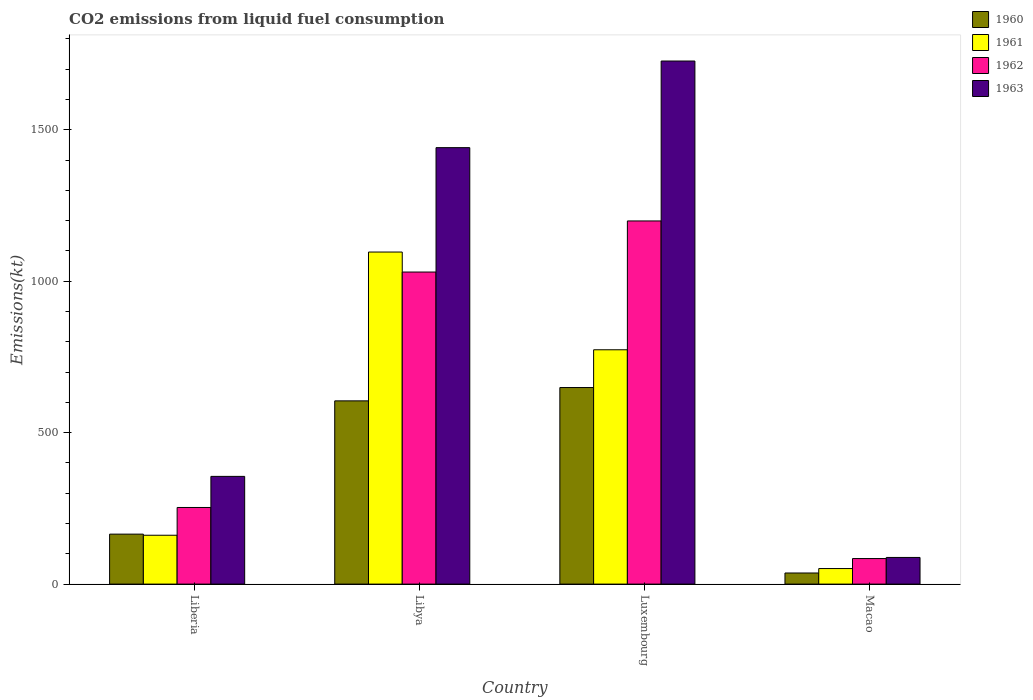How many groups of bars are there?
Your answer should be compact. 4. Are the number of bars on each tick of the X-axis equal?
Your answer should be compact. Yes. How many bars are there on the 2nd tick from the left?
Provide a short and direct response. 4. What is the label of the 3rd group of bars from the left?
Your answer should be very brief. Luxembourg. In how many cases, is the number of bars for a given country not equal to the number of legend labels?
Your answer should be very brief. 0. What is the amount of CO2 emitted in 1960 in Macao?
Your response must be concise. 36.67. Across all countries, what is the maximum amount of CO2 emitted in 1961?
Make the answer very short. 1096.43. Across all countries, what is the minimum amount of CO2 emitted in 1962?
Your answer should be very brief. 84.34. In which country was the amount of CO2 emitted in 1962 maximum?
Provide a succinct answer. Luxembourg. In which country was the amount of CO2 emitted in 1963 minimum?
Offer a very short reply. Macao. What is the total amount of CO2 emitted in 1963 in the graph?
Your answer should be very brief. 3611.99. What is the difference between the amount of CO2 emitted in 1960 in Libya and that in Macao?
Your response must be concise. 568.38. What is the difference between the amount of CO2 emitted in 1963 in Luxembourg and the amount of CO2 emitted in 1960 in Liberia?
Your answer should be very brief. 1562.14. What is the average amount of CO2 emitted in 1962 per country?
Ensure brevity in your answer.  641.72. What is the difference between the amount of CO2 emitted of/in 1960 and amount of CO2 emitted of/in 1963 in Liberia?
Offer a terse response. -190.68. In how many countries, is the amount of CO2 emitted in 1963 greater than 900 kt?
Make the answer very short. 2. What is the ratio of the amount of CO2 emitted in 1962 in Liberia to that in Luxembourg?
Ensure brevity in your answer.  0.21. Is the amount of CO2 emitted in 1961 in Luxembourg less than that in Macao?
Give a very brief answer. No. Is the difference between the amount of CO2 emitted in 1960 in Libya and Luxembourg greater than the difference between the amount of CO2 emitted in 1963 in Libya and Luxembourg?
Offer a terse response. Yes. What is the difference between the highest and the second highest amount of CO2 emitted in 1963?
Offer a terse response. 1085.43. What is the difference between the highest and the lowest amount of CO2 emitted in 1961?
Provide a short and direct response. 1045.1. Is the sum of the amount of CO2 emitted in 1961 in Luxembourg and Macao greater than the maximum amount of CO2 emitted in 1960 across all countries?
Offer a terse response. Yes. Is it the case that in every country, the sum of the amount of CO2 emitted in 1963 and amount of CO2 emitted in 1960 is greater than the sum of amount of CO2 emitted in 1961 and amount of CO2 emitted in 1962?
Provide a succinct answer. No. What does the 2nd bar from the left in Liberia represents?
Give a very brief answer. 1961. Is it the case that in every country, the sum of the amount of CO2 emitted in 1962 and amount of CO2 emitted in 1960 is greater than the amount of CO2 emitted in 1961?
Offer a terse response. Yes. How many bars are there?
Keep it short and to the point. 16. How many countries are there in the graph?
Offer a terse response. 4. What is the difference between two consecutive major ticks on the Y-axis?
Give a very brief answer. 500. Does the graph contain any zero values?
Keep it short and to the point. No. How many legend labels are there?
Provide a succinct answer. 4. How are the legend labels stacked?
Your response must be concise. Vertical. What is the title of the graph?
Ensure brevity in your answer.  CO2 emissions from liquid fuel consumption. What is the label or title of the X-axis?
Keep it short and to the point. Country. What is the label or title of the Y-axis?
Provide a succinct answer. Emissions(kt). What is the Emissions(kt) in 1960 in Liberia?
Make the answer very short. 165.01. What is the Emissions(kt) of 1961 in Liberia?
Your response must be concise. 161.35. What is the Emissions(kt) in 1962 in Liberia?
Offer a terse response. 253.02. What is the Emissions(kt) of 1963 in Liberia?
Offer a very short reply. 355.7. What is the Emissions(kt) in 1960 in Libya?
Offer a very short reply. 605.05. What is the Emissions(kt) in 1961 in Libya?
Give a very brief answer. 1096.43. What is the Emissions(kt) in 1962 in Libya?
Your answer should be compact. 1030.43. What is the Emissions(kt) in 1963 in Libya?
Your answer should be very brief. 1441.13. What is the Emissions(kt) of 1960 in Luxembourg?
Give a very brief answer. 649.06. What is the Emissions(kt) of 1961 in Luxembourg?
Give a very brief answer. 773.74. What is the Emissions(kt) of 1962 in Luxembourg?
Provide a succinct answer. 1199.11. What is the Emissions(kt) in 1963 in Luxembourg?
Offer a very short reply. 1727.16. What is the Emissions(kt) of 1960 in Macao?
Offer a terse response. 36.67. What is the Emissions(kt) in 1961 in Macao?
Provide a succinct answer. 51.34. What is the Emissions(kt) of 1962 in Macao?
Offer a very short reply. 84.34. What is the Emissions(kt) in 1963 in Macao?
Your answer should be very brief. 88.01. Across all countries, what is the maximum Emissions(kt) of 1960?
Your response must be concise. 649.06. Across all countries, what is the maximum Emissions(kt) of 1961?
Offer a very short reply. 1096.43. Across all countries, what is the maximum Emissions(kt) of 1962?
Make the answer very short. 1199.11. Across all countries, what is the maximum Emissions(kt) in 1963?
Make the answer very short. 1727.16. Across all countries, what is the minimum Emissions(kt) of 1960?
Ensure brevity in your answer.  36.67. Across all countries, what is the minimum Emissions(kt) in 1961?
Keep it short and to the point. 51.34. Across all countries, what is the minimum Emissions(kt) in 1962?
Your response must be concise. 84.34. Across all countries, what is the minimum Emissions(kt) of 1963?
Give a very brief answer. 88.01. What is the total Emissions(kt) of 1960 in the graph?
Your answer should be compact. 1455.8. What is the total Emissions(kt) in 1961 in the graph?
Ensure brevity in your answer.  2082.86. What is the total Emissions(kt) in 1962 in the graph?
Give a very brief answer. 2566.9. What is the total Emissions(kt) of 1963 in the graph?
Provide a succinct answer. 3611.99. What is the difference between the Emissions(kt) of 1960 in Liberia and that in Libya?
Provide a succinct answer. -440.04. What is the difference between the Emissions(kt) in 1961 in Liberia and that in Libya?
Give a very brief answer. -935.09. What is the difference between the Emissions(kt) in 1962 in Liberia and that in Libya?
Your response must be concise. -777.4. What is the difference between the Emissions(kt) in 1963 in Liberia and that in Libya?
Your answer should be compact. -1085.43. What is the difference between the Emissions(kt) of 1960 in Liberia and that in Luxembourg?
Your answer should be very brief. -484.04. What is the difference between the Emissions(kt) in 1961 in Liberia and that in Luxembourg?
Keep it short and to the point. -612.39. What is the difference between the Emissions(kt) in 1962 in Liberia and that in Luxembourg?
Ensure brevity in your answer.  -946.09. What is the difference between the Emissions(kt) of 1963 in Liberia and that in Luxembourg?
Give a very brief answer. -1371.46. What is the difference between the Emissions(kt) in 1960 in Liberia and that in Macao?
Make the answer very short. 128.34. What is the difference between the Emissions(kt) of 1961 in Liberia and that in Macao?
Make the answer very short. 110.01. What is the difference between the Emissions(kt) in 1962 in Liberia and that in Macao?
Your response must be concise. 168.68. What is the difference between the Emissions(kt) in 1963 in Liberia and that in Macao?
Your answer should be very brief. 267.69. What is the difference between the Emissions(kt) in 1960 in Libya and that in Luxembourg?
Make the answer very short. -44. What is the difference between the Emissions(kt) of 1961 in Libya and that in Luxembourg?
Make the answer very short. 322.7. What is the difference between the Emissions(kt) in 1962 in Libya and that in Luxembourg?
Offer a terse response. -168.68. What is the difference between the Emissions(kt) in 1963 in Libya and that in Luxembourg?
Your answer should be compact. -286.03. What is the difference between the Emissions(kt) in 1960 in Libya and that in Macao?
Provide a short and direct response. 568.38. What is the difference between the Emissions(kt) of 1961 in Libya and that in Macao?
Provide a short and direct response. 1045.1. What is the difference between the Emissions(kt) in 1962 in Libya and that in Macao?
Your answer should be very brief. 946.09. What is the difference between the Emissions(kt) in 1963 in Libya and that in Macao?
Give a very brief answer. 1353.12. What is the difference between the Emissions(kt) in 1960 in Luxembourg and that in Macao?
Your response must be concise. 612.39. What is the difference between the Emissions(kt) of 1961 in Luxembourg and that in Macao?
Ensure brevity in your answer.  722.4. What is the difference between the Emissions(kt) in 1962 in Luxembourg and that in Macao?
Offer a terse response. 1114.77. What is the difference between the Emissions(kt) of 1963 in Luxembourg and that in Macao?
Your answer should be compact. 1639.15. What is the difference between the Emissions(kt) of 1960 in Liberia and the Emissions(kt) of 1961 in Libya?
Keep it short and to the point. -931.42. What is the difference between the Emissions(kt) in 1960 in Liberia and the Emissions(kt) in 1962 in Libya?
Your answer should be compact. -865.41. What is the difference between the Emissions(kt) in 1960 in Liberia and the Emissions(kt) in 1963 in Libya?
Give a very brief answer. -1276.12. What is the difference between the Emissions(kt) of 1961 in Liberia and the Emissions(kt) of 1962 in Libya?
Your answer should be compact. -869.08. What is the difference between the Emissions(kt) in 1961 in Liberia and the Emissions(kt) in 1963 in Libya?
Provide a succinct answer. -1279.78. What is the difference between the Emissions(kt) of 1962 in Liberia and the Emissions(kt) of 1963 in Libya?
Your answer should be very brief. -1188.11. What is the difference between the Emissions(kt) of 1960 in Liberia and the Emissions(kt) of 1961 in Luxembourg?
Give a very brief answer. -608.72. What is the difference between the Emissions(kt) in 1960 in Liberia and the Emissions(kt) in 1962 in Luxembourg?
Provide a succinct answer. -1034.09. What is the difference between the Emissions(kt) in 1960 in Liberia and the Emissions(kt) in 1963 in Luxembourg?
Offer a very short reply. -1562.14. What is the difference between the Emissions(kt) of 1961 in Liberia and the Emissions(kt) of 1962 in Luxembourg?
Ensure brevity in your answer.  -1037.76. What is the difference between the Emissions(kt) of 1961 in Liberia and the Emissions(kt) of 1963 in Luxembourg?
Give a very brief answer. -1565.81. What is the difference between the Emissions(kt) in 1962 in Liberia and the Emissions(kt) in 1963 in Luxembourg?
Your answer should be very brief. -1474.13. What is the difference between the Emissions(kt) in 1960 in Liberia and the Emissions(kt) in 1961 in Macao?
Give a very brief answer. 113.68. What is the difference between the Emissions(kt) in 1960 in Liberia and the Emissions(kt) in 1962 in Macao?
Offer a terse response. 80.67. What is the difference between the Emissions(kt) of 1960 in Liberia and the Emissions(kt) of 1963 in Macao?
Offer a terse response. 77.01. What is the difference between the Emissions(kt) in 1961 in Liberia and the Emissions(kt) in 1962 in Macao?
Provide a short and direct response. 77.01. What is the difference between the Emissions(kt) of 1961 in Liberia and the Emissions(kt) of 1963 in Macao?
Offer a very short reply. 73.34. What is the difference between the Emissions(kt) in 1962 in Liberia and the Emissions(kt) in 1963 in Macao?
Keep it short and to the point. 165.01. What is the difference between the Emissions(kt) of 1960 in Libya and the Emissions(kt) of 1961 in Luxembourg?
Your answer should be compact. -168.68. What is the difference between the Emissions(kt) of 1960 in Libya and the Emissions(kt) of 1962 in Luxembourg?
Your answer should be very brief. -594.05. What is the difference between the Emissions(kt) of 1960 in Libya and the Emissions(kt) of 1963 in Luxembourg?
Keep it short and to the point. -1122.1. What is the difference between the Emissions(kt) in 1961 in Libya and the Emissions(kt) in 1962 in Luxembourg?
Offer a very short reply. -102.68. What is the difference between the Emissions(kt) of 1961 in Libya and the Emissions(kt) of 1963 in Luxembourg?
Your answer should be compact. -630.72. What is the difference between the Emissions(kt) in 1962 in Libya and the Emissions(kt) in 1963 in Luxembourg?
Your response must be concise. -696.73. What is the difference between the Emissions(kt) of 1960 in Libya and the Emissions(kt) of 1961 in Macao?
Offer a very short reply. 553.72. What is the difference between the Emissions(kt) in 1960 in Libya and the Emissions(kt) in 1962 in Macao?
Provide a short and direct response. 520.71. What is the difference between the Emissions(kt) in 1960 in Libya and the Emissions(kt) in 1963 in Macao?
Make the answer very short. 517.05. What is the difference between the Emissions(kt) of 1961 in Libya and the Emissions(kt) of 1962 in Macao?
Your response must be concise. 1012.09. What is the difference between the Emissions(kt) in 1961 in Libya and the Emissions(kt) in 1963 in Macao?
Make the answer very short. 1008.42. What is the difference between the Emissions(kt) of 1962 in Libya and the Emissions(kt) of 1963 in Macao?
Ensure brevity in your answer.  942.42. What is the difference between the Emissions(kt) in 1960 in Luxembourg and the Emissions(kt) in 1961 in Macao?
Offer a terse response. 597.72. What is the difference between the Emissions(kt) of 1960 in Luxembourg and the Emissions(kt) of 1962 in Macao?
Provide a short and direct response. 564.72. What is the difference between the Emissions(kt) in 1960 in Luxembourg and the Emissions(kt) in 1963 in Macao?
Provide a short and direct response. 561.05. What is the difference between the Emissions(kt) in 1961 in Luxembourg and the Emissions(kt) in 1962 in Macao?
Offer a very short reply. 689.4. What is the difference between the Emissions(kt) of 1961 in Luxembourg and the Emissions(kt) of 1963 in Macao?
Provide a succinct answer. 685.73. What is the difference between the Emissions(kt) in 1962 in Luxembourg and the Emissions(kt) in 1963 in Macao?
Ensure brevity in your answer.  1111.1. What is the average Emissions(kt) of 1960 per country?
Provide a short and direct response. 363.95. What is the average Emissions(kt) of 1961 per country?
Keep it short and to the point. 520.71. What is the average Emissions(kt) of 1962 per country?
Make the answer very short. 641.73. What is the average Emissions(kt) in 1963 per country?
Your answer should be compact. 903. What is the difference between the Emissions(kt) of 1960 and Emissions(kt) of 1961 in Liberia?
Your answer should be compact. 3.67. What is the difference between the Emissions(kt) of 1960 and Emissions(kt) of 1962 in Liberia?
Offer a very short reply. -88.01. What is the difference between the Emissions(kt) of 1960 and Emissions(kt) of 1963 in Liberia?
Your answer should be compact. -190.68. What is the difference between the Emissions(kt) in 1961 and Emissions(kt) in 1962 in Liberia?
Keep it short and to the point. -91.67. What is the difference between the Emissions(kt) of 1961 and Emissions(kt) of 1963 in Liberia?
Give a very brief answer. -194.35. What is the difference between the Emissions(kt) in 1962 and Emissions(kt) in 1963 in Liberia?
Your answer should be very brief. -102.68. What is the difference between the Emissions(kt) in 1960 and Emissions(kt) in 1961 in Libya?
Your answer should be very brief. -491.38. What is the difference between the Emissions(kt) of 1960 and Emissions(kt) of 1962 in Libya?
Offer a terse response. -425.37. What is the difference between the Emissions(kt) in 1960 and Emissions(kt) in 1963 in Libya?
Give a very brief answer. -836.08. What is the difference between the Emissions(kt) of 1961 and Emissions(kt) of 1962 in Libya?
Keep it short and to the point. 66.01. What is the difference between the Emissions(kt) of 1961 and Emissions(kt) of 1963 in Libya?
Provide a succinct answer. -344.7. What is the difference between the Emissions(kt) of 1962 and Emissions(kt) of 1963 in Libya?
Your answer should be very brief. -410.7. What is the difference between the Emissions(kt) of 1960 and Emissions(kt) of 1961 in Luxembourg?
Give a very brief answer. -124.68. What is the difference between the Emissions(kt) of 1960 and Emissions(kt) of 1962 in Luxembourg?
Offer a terse response. -550.05. What is the difference between the Emissions(kt) of 1960 and Emissions(kt) of 1963 in Luxembourg?
Offer a terse response. -1078.1. What is the difference between the Emissions(kt) of 1961 and Emissions(kt) of 1962 in Luxembourg?
Make the answer very short. -425.37. What is the difference between the Emissions(kt) of 1961 and Emissions(kt) of 1963 in Luxembourg?
Provide a short and direct response. -953.42. What is the difference between the Emissions(kt) in 1962 and Emissions(kt) in 1963 in Luxembourg?
Give a very brief answer. -528.05. What is the difference between the Emissions(kt) in 1960 and Emissions(kt) in 1961 in Macao?
Keep it short and to the point. -14.67. What is the difference between the Emissions(kt) in 1960 and Emissions(kt) in 1962 in Macao?
Offer a very short reply. -47.67. What is the difference between the Emissions(kt) of 1960 and Emissions(kt) of 1963 in Macao?
Keep it short and to the point. -51.34. What is the difference between the Emissions(kt) in 1961 and Emissions(kt) in 1962 in Macao?
Your answer should be compact. -33. What is the difference between the Emissions(kt) in 1961 and Emissions(kt) in 1963 in Macao?
Keep it short and to the point. -36.67. What is the difference between the Emissions(kt) in 1962 and Emissions(kt) in 1963 in Macao?
Your answer should be compact. -3.67. What is the ratio of the Emissions(kt) in 1960 in Liberia to that in Libya?
Your answer should be very brief. 0.27. What is the ratio of the Emissions(kt) in 1961 in Liberia to that in Libya?
Offer a very short reply. 0.15. What is the ratio of the Emissions(kt) in 1962 in Liberia to that in Libya?
Your answer should be very brief. 0.25. What is the ratio of the Emissions(kt) in 1963 in Liberia to that in Libya?
Provide a short and direct response. 0.25. What is the ratio of the Emissions(kt) of 1960 in Liberia to that in Luxembourg?
Your answer should be very brief. 0.25. What is the ratio of the Emissions(kt) of 1961 in Liberia to that in Luxembourg?
Keep it short and to the point. 0.21. What is the ratio of the Emissions(kt) of 1962 in Liberia to that in Luxembourg?
Keep it short and to the point. 0.21. What is the ratio of the Emissions(kt) of 1963 in Liberia to that in Luxembourg?
Offer a terse response. 0.21. What is the ratio of the Emissions(kt) in 1961 in Liberia to that in Macao?
Provide a succinct answer. 3.14. What is the ratio of the Emissions(kt) of 1963 in Liberia to that in Macao?
Offer a very short reply. 4.04. What is the ratio of the Emissions(kt) of 1960 in Libya to that in Luxembourg?
Provide a succinct answer. 0.93. What is the ratio of the Emissions(kt) in 1961 in Libya to that in Luxembourg?
Your answer should be compact. 1.42. What is the ratio of the Emissions(kt) in 1962 in Libya to that in Luxembourg?
Your answer should be very brief. 0.86. What is the ratio of the Emissions(kt) of 1963 in Libya to that in Luxembourg?
Offer a very short reply. 0.83. What is the ratio of the Emissions(kt) of 1961 in Libya to that in Macao?
Your answer should be compact. 21.36. What is the ratio of the Emissions(kt) of 1962 in Libya to that in Macao?
Provide a short and direct response. 12.22. What is the ratio of the Emissions(kt) of 1963 in Libya to that in Macao?
Ensure brevity in your answer.  16.38. What is the ratio of the Emissions(kt) of 1961 in Luxembourg to that in Macao?
Keep it short and to the point. 15.07. What is the ratio of the Emissions(kt) in 1962 in Luxembourg to that in Macao?
Provide a short and direct response. 14.22. What is the ratio of the Emissions(kt) of 1963 in Luxembourg to that in Macao?
Offer a terse response. 19.62. What is the difference between the highest and the second highest Emissions(kt) in 1960?
Provide a succinct answer. 44. What is the difference between the highest and the second highest Emissions(kt) in 1961?
Your answer should be compact. 322.7. What is the difference between the highest and the second highest Emissions(kt) of 1962?
Make the answer very short. 168.68. What is the difference between the highest and the second highest Emissions(kt) in 1963?
Provide a short and direct response. 286.03. What is the difference between the highest and the lowest Emissions(kt) of 1960?
Provide a succinct answer. 612.39. What is the difference between the highest and the lowest Emissions(kt) of 1961?
Offer a terse response. 1045.1. What is the difference between the highest and the lowest Emissions(kt) in 1962?
Ensure brevity in your answer.  1114.77. What is the difference between the highest and the lowest Emissions(kt) in 1963?
Offer a very short reply. 1639.15. 